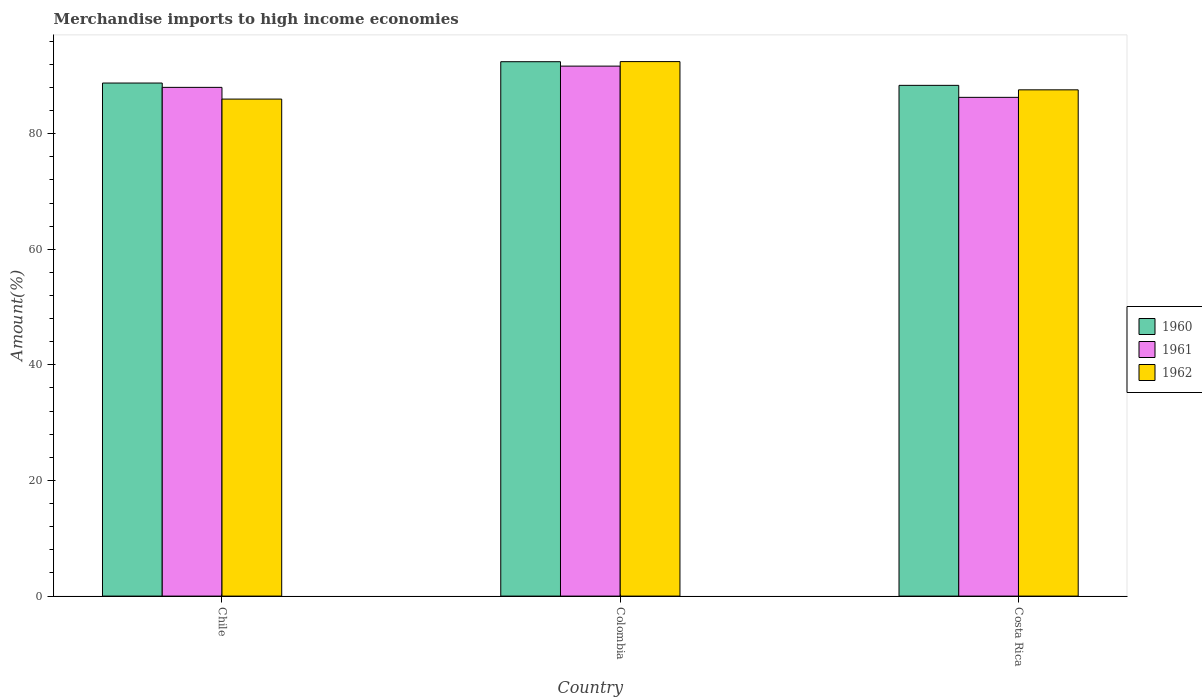How many groups of bars are there?
Offer a terse response. 3. Are the number of bars per tick equal to the number of legend labels?
Ensure brevity in your answer.  Yes. What is the label of the 2nd group of bars from the left?
Give a very brief answer. Colombia. In how many cases, is the number of bars for a given country not equal to the number of legend labels?
Offer a terse response. 0. What is the percentage of amount earned from merchandise imports in 1960 in Colombia?
Your answer should be compact. 92.44. Across all countries, what is the maximum percentage of amount earned from merchandise imports in 1962?
Provide a succinct answer. 92.46. Across all countries, what is the minimum percentage of amount earned from merchandise imports in 1962?
Keep it short and to the point. 85.98. In which country was the percentage of amount earned from merchandise imports in 1960 maximum?
Your response must be concise. Colombia. In which country was the percentage of amount earned from merchandise imports in 1960 minimum?
Your answer should be compact. Costa Rica. What is the total percentage of amount earned from merchandise imports in 1960 in the graph?
Make the answer very short. 269.55. What is the difference between the percentage of amount earned from merchandise imports in 1960 in Chile and that in Costa Rica?
Provide a succinct answer. 0.4. What is the difference between the percentage of amount earned from merchandise imports in 1961 in Colombia and the percentage of amount earned from merchandise imports in 1960 in Chile?
Offer a very short reply. 2.93. What is the average percentage of amount earned from merchandise imports in 1961 per country?
Keep it short and to the point. 88.65. What is the difference between the percentage of amount earned from merchandise imports of/in 1962 and percentage of amount earned from merchandise imports of/in 1960 in Colombia?
Your response must be concise. 0.02. In how many countries, is the percentage of amount earned from merchandise imports in 1960 greater than 76 %?
Provide a short and direct response. 3. What is the ratio of the percentage of amount earned from merchandise imports in 1961 in Chile to that in Costa Rica?
Keep it short and to the point. 1.02. Is the percentage of amount earned from merchandise imports in 1962 in Colombia less than that in Costa Rica?
Offer a very short reply. No. Is the difference between the percentage of amount earned from merchandise imports in 1962 in Colombia and Costa Rica greater than the difference between the percentage of amount earned from merchandise imports in 1960 in Colombia and Costa Rica?
Keep it short and to the point. Yes. What is the difference between the highest and the second highest percentage of amount earned from merchandise imports in 1960?
Offer a very short reply. 0.4. What is the difference between the highest and the lowest percentage of amount earned from merchandise imports in 1961?
Provide a short and direct response. 5.4. What does the 2nd bar from the right in Chile represents?
Ensure brevity in your answer.  1961. How many bars are there?
Your answer should be compact. 9. What is the difference between two consecutive major ticks on the Y-axis?
Keep it short and to the point. 20. Does the graph contain any zero values?
Provide a succinct answer. No. Where does the legend appear in the graph?
Ensure brevity in your answer.  Center right. How are the legend labels stacked?
Provide a short and direct response. Vertical. What is the title of the graph?
Provide a succinct answer. Merchandise imports to high income economies. Does "2005" appear as one of the legend labels in the graph?
Keep it short and to the point. No. What is the label or title of the X-axis?
Your response must be concise. Country. What is the label or title of the Y-axis?
Keep it short and to the point. Amount(%). What is the Amount(%) in 1960 in Chile?
Your response must be concise. 88.75. What is the Amount(%) of 1961 in Chile?
Provide a short and direct response. 88. What is the Amount(%) in 1962 in Chile?
Ensure brevity in your answer.  85.98. What is the Amount(%) of 1960 in Colombia?
Keep it short and to the point. 92.44. What is the Amount(%) of 1961 in Colombia?
Give a very brief answer. 91.68. What is the Amount(%) of 1962 in Colombia?
Ensure brevity in your answer.  92.46. What is the Amount(%) of 1960 in Costa Rica?
Give a very brief answer. 88.35. What is the Amount(%) in 1961 in Costa Rica?
Give a very brief answer. 86.28. What is the Amount(%) of 1962 in Costa Rica?
Provide a succinct answer. 87.58. Across all countries, what is the maximum Amount(%) of 1960?
Make the answer very short. 92.44. Across all countries, what is the maximum Amount(%) of 1961?
Your response must be concise. 91.68. Across all countries, what is the maximum Amount(%) in 1962?
Provide a succinct answer. 92.46. Across all countries, what is the minimum Amount(%) of 1960?
Your answer should be compact. 88.35. Across all countries, what is the minimum Amount(%) of 1961?
Offer a terse response. 86.28. Across all countries, what is the minimum Amount(%) in 1962?
Ensure brevity in your answer.  85.98. What is the total Amount(%) in 1960 in the graph?
Your answer should be very brief. 269.55. What is the total Amount(%) in 1961 in the graph?
Give a very brief answer. 265.96. What is the total Amount(%) in 1962 in the graph?
Your answer should be compact. 266.02. What is the difference between the Amount(%) in 1960 in Chile and that in Colombia?
Make the answer very short. -3.69. What is the difference between the Amount(%) of 1961 in Chile and that in Colombia?
Your answer should be very brief. -3.68. What is the difference between the Amount(%) of 1962 in Chile and that in Colombia?
Keep it short and to the point. -6.49. What is the difference between the Amount(%) of 1961 in Chile and that in Costa Rica?
Make the answer very short. 1.73. What is the difference between the Amount(%) of 1962 in Chile and that in Costa Rica?
Ensure brevity in your answer.  -1.6. What is the difference between the Amount(%) of 1960 in Colombia and that in Costa Rica?
Give a very brief answer. 4.09. What is the difference between the Amount(%) in 1961 in Colombia and that in Costa Rica?
Ensure brevity in your answer.  5.4. What is the difference between the Amount(%) in 1962 in Colombia and that in Costa Rica?
Make the answer very short. 4.88. What is the difference between the Amount(%) in 1960 in Chile and the Amount(%) in 1961 in Colombia?
Give a very brief answer. -2.93. What is the difference between the Amount(%) of 1960 in Chile and the Amount(%) of 1962 in Colombia?
Provide a short and direct response. -3.71. What is the difference between the Amount(%) in 1961 in Chile and the Amount(%) in 1962 in Colombia?
Keep it short and to the point. -4.46. What is the difference between the Amount(%) of 1960 in Chile and the Amount(%) of 1961 in Costa Rica?
Make the answer very short. 2.47. What is the difference between the Amount(%) in 1960 in Chile and the Amount(%) in 1962 in Costa Rica?
Give a very brief answer. 1.17. What is the difference between the Amount(%) of 1961 in Chile and the Amount(%) of 1962 in Costa Rica?
Ensure brevity in your answer.  0.43. What is the difference between the Amount(%) of 1960 in Colombia and the Amount(%) of 1961 in Costa Rica?
Provide a short and direct response. 6.16. What is the difference between the Amount(%) in 1960 in Colombia and the Amount(%) in 1962 in Costa Rica?
Make the answer very short. 4.86. What is the difference between the Amount(%) in 1961 in Colombia and the Amount(%) in 1962 in Costa Rica?
Make the answer very short. 4.1. What is the average Amount(%) in 1960 per country?
Provide a short and direct response. 89.85. What is the average Amount(%) in 1961 per country?
Offer a terse response. 88.65. What is the average Amount(%) of 1962 per country?
Provide a succinct answer. 88.67. What is the difference between the Amount(%) of 1960 and Amount(%) of 1961 in Chile?
Your answer should be compact. 0.75. What is the difference between the Amount(%) of 1960 and Amount(%) of 1962 in Chile?
Your answer should be very brief. 2.78. What is the difference between the Amount(%) in 1961 and Amount(%) in 1962 in Chile?
Keep it short and to the point. 2.03. What is the difference between the Amount(%) of 1960 and Amount(%) of 1961 in Colombia?
Provide a short and direct response. 0.76. What is the difference between the Amount(%) in 1960 and Amount(%) in 1962 in Colombia?
Your response must be concise. -0.02. What is the difference between the Amount(%) in 1961 and Amount(%) in 1962 in Colombia?
Make the answer very short. -0.78. What is the difference between the Amount(%) of 1960 and Amount(%) of 1961 in Costa Rica?
Offer a very short reply. 2.07. What is the difference between the Amount(%) of 1960 and Amount(%) of 1962 in Costa Rica?
Your response must be concise. 0.77. What is the difference between the Amount(%) of 1961 and Amount(%) of 1962 in Costa Rica?
Your response must be concise. -1.3. What is the ratio of the Amount(%) in 1960 in Chile to that in Colombia?
Keep it short and to the point. 0.96. What is the ratio of the Amount(%) of 1961 in Chile to that in Colombia?
Ensure brevity in your answer.  0.96. What is the ratio of the Amount(%) in 1962 in Chile to that in Colombia?
Offer a terse response. 0.93. What is the ratio of the Amount(%) in 1960 in Chile to that in Costa Rica?
Provide a succinct answer. 1. What is the ratio of the Amount(%) of 1961 in Chile to that in Costa Rica?
Offer a terse response. 1.02. What is the ratio of the Amount(%) in 1962 in Chile to that in Costa Rica?
Offer a very short reply. 0.98. What is the ratio of the Amount(%) of 1960 in Colombia to that in Costa Rica?
Make the answer very short. 1.05. What is the ratio of the Amount(%) in 1961 in Colombia to that in Costa Rica?
Your answer should be very brief. 1.06. What is the ratio of the Amount(%) of 1962 in Colombia to that in Costa Rica?
Your answer should be very brief. 1.06. What is the difference between the highest and the second highest Amount(%) in 1960?
Give a very brief answer. 3.69. What is the difference between the highest and the second highest Amount(%) in 1961?
Your answer should be compact. 3.68. What is the difference between the highest and the second highest Amount(%) in 1962?
Your answer should be very brief. 4.88. What is the difference between the highest and the lowest Amount(%) of 1960?
Provide a succinct answer. 4.09. What is the difference between the highest and the lowest Amount(%) of 1961?
Provide a short and direct response. 5.4. What is the difference between the highest and the lowest Amount(%) of 1962?
Offer a terse response. 6.49. 